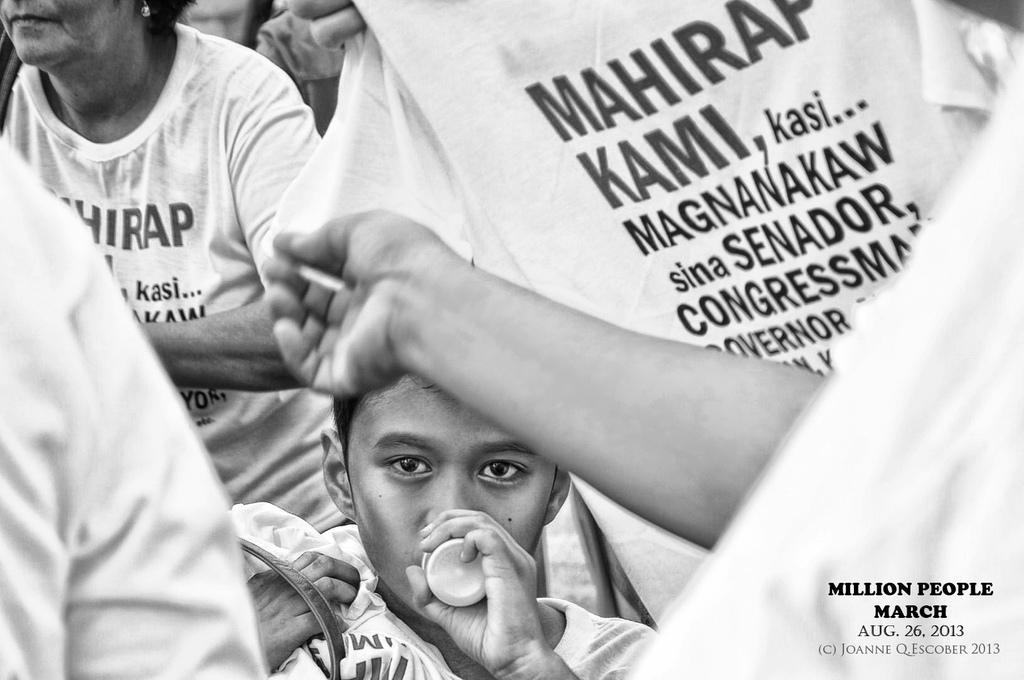Please provide a concise description of this image. It is a black and white picture. In the center of the image we can see a few people. On the t shirts, we can see some text. And we can see the boy is holding some objects. At the bottom right side of the image, we can see some text. 